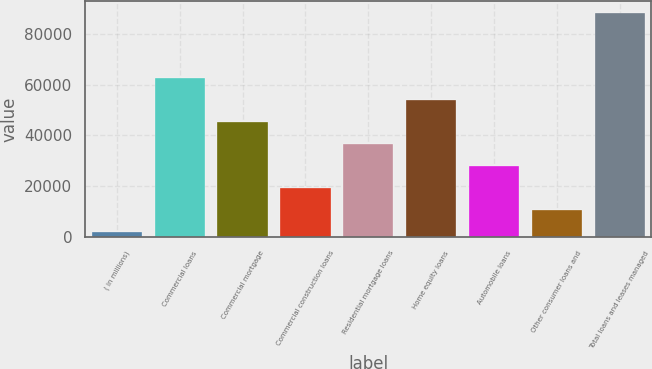<chart> <loc_0><loc_0><loc_500><loc_500><bar_chart><fcel>( in millions)<fcel>Commercial loans<fcel>Commercial mortgage<fcel>Commercial construction loans<fcel>Residential mortgage loans<fcel>Home equity loans<fcel>Automobile loans<fcel>Other consumer loans and<fcel>Total loans and leases managed<nl><fcel>2008<fcel>62495<fcel>45213<fcel>19290<fcel>36572<fcel>53854<fcel>27931<fcel>10649<fcel>88418<nl></chart> 